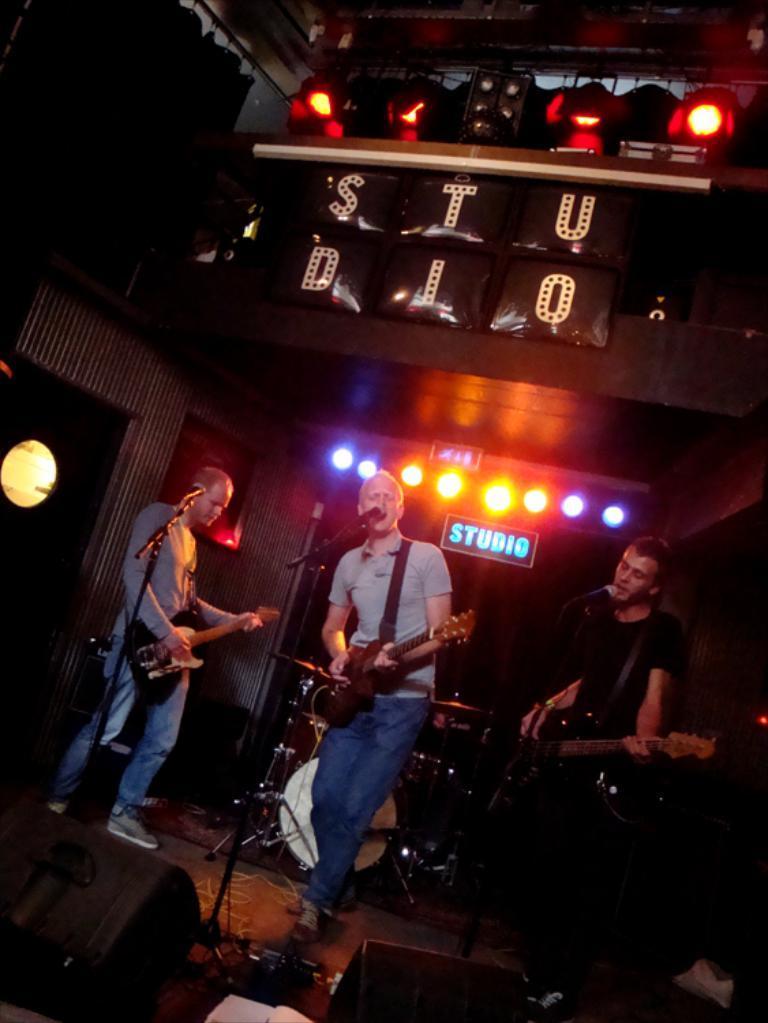Describe this image in one or two sentences. This image is clicked in a concert. There are three men in this image. In the middle, the man is singing and playing guitar. To the right, the man is singing and playing guitar. At the top, there are lights. In the background, there are lights and a band setup. At the bottom there are speakers. 